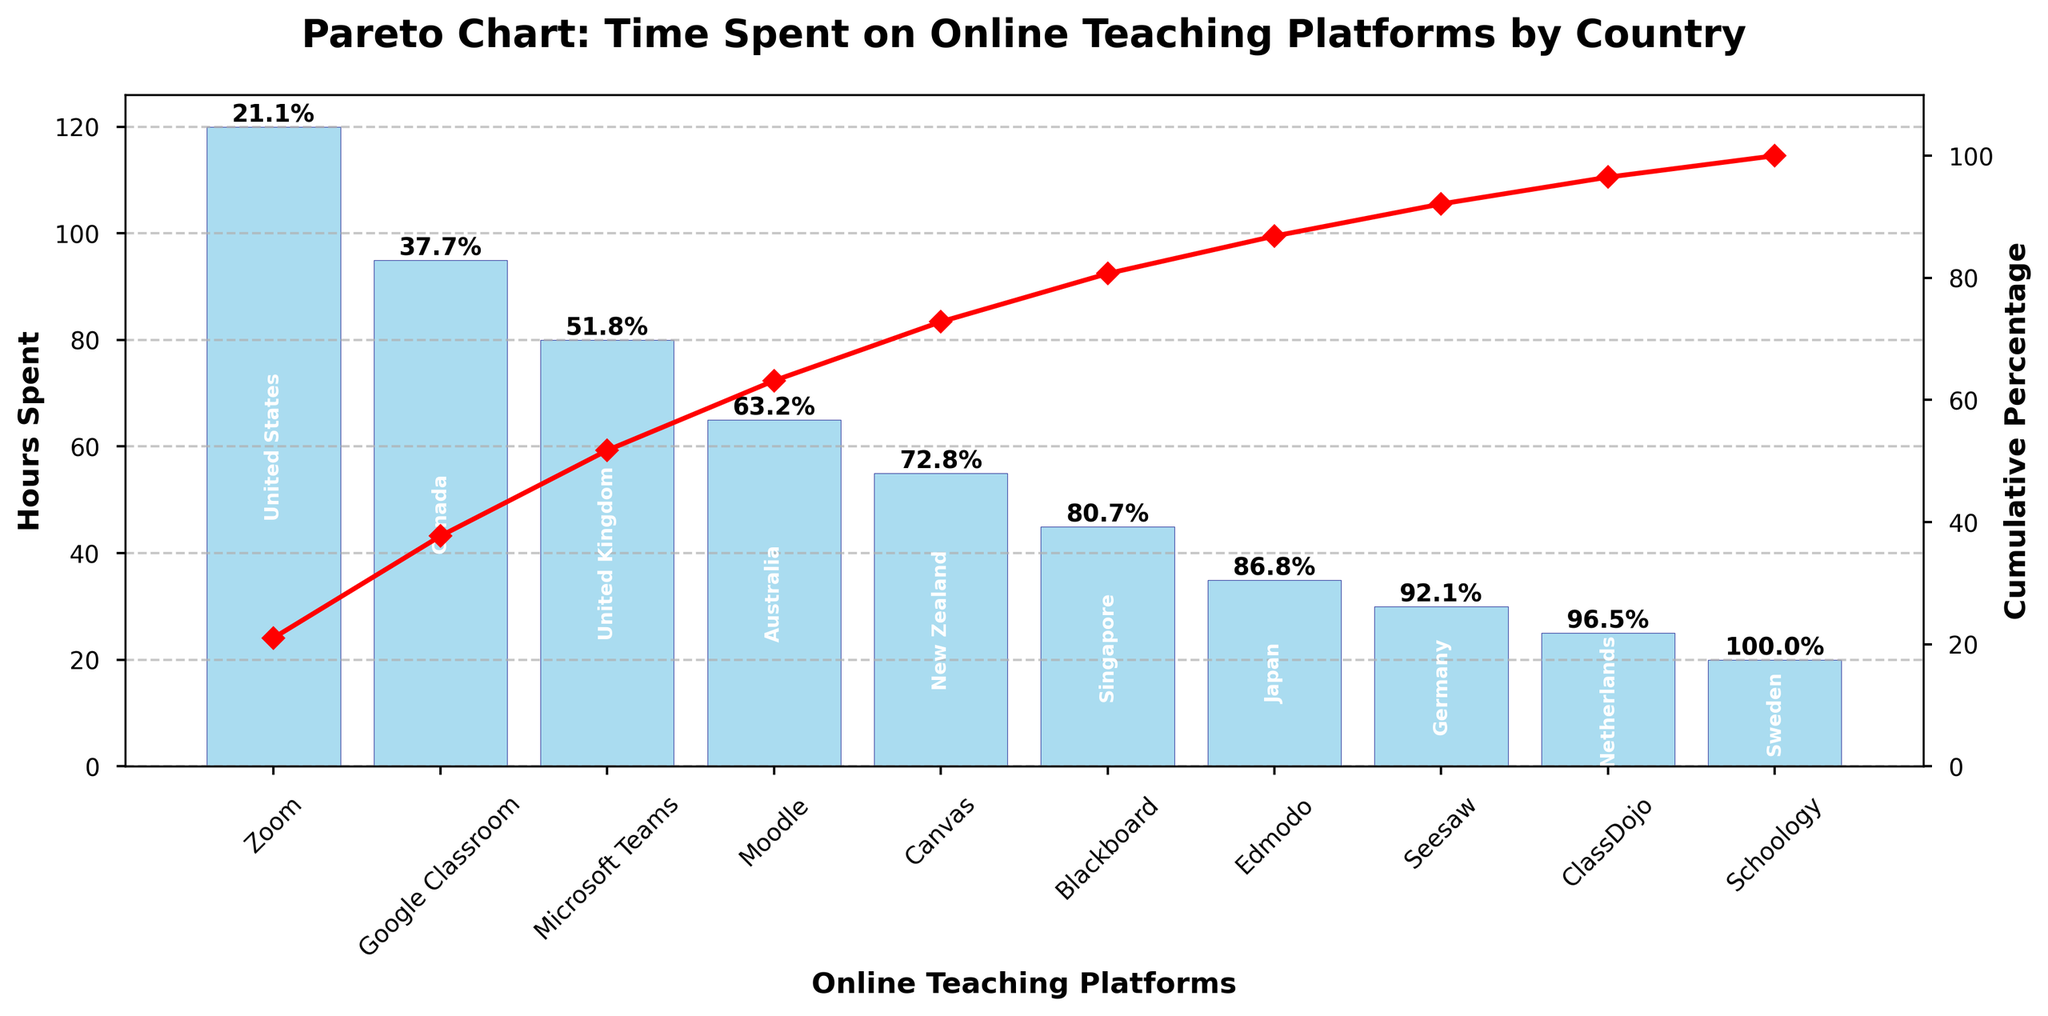What is the title of the figure? The title can be found at the top of the figure, which generally provides a summary of what the figure represents. In this case, it is "Pareto Chart: Time Spent on Online Teaching Platforms by Country"
Answer: Pareto Chart: Time Spent on Online Teaching Platforms by Country Which online teaching platform has the highest hours spent? To find this, look at the highest bar in the figure. The label underneath the tallest bar will indicate the platform.
Answer: Zoom How many hours were spent on the platform Seesaw? To find this information, locate the bar labeled Seesaw and read the height of the bar, which corresponds to the hours spent.
Answer: 30 What is the cumulative percentage after the third platform according to hours spent? Summing the hours of the top three platforms (Zoom, Google Classroom, and Microsoft Teams) gives us 120 + 95 + 80 = 295. Dividing this by the total hours and multiplying by 100 gives the cumulative percentage. The exact values are marked on the chart.
Answer: 64.2% Which country spent time on the platform Canvas? The name of the country for each platform is labeled inside the corresponding bar. Locate the bar for Canvas and find the country label.
Answer: New Zealand What is the total number of hours spent on all platforms? Sum the hours spent on all platforms using the heights of the bars: (120 + 95 + 80 + 65 + 55 + 45 + 35 + 30 + 25 + 20). Adding these together gives 570 hours.
Answer: 570 How much more time was spent on Zoom compared to Edmodo? Subtract the hours spent on Edmodo from the hours spent on Zoom. 120 (Zoom) - 35 (Edmodo) = 85.
Answer: 85 Which platform contribute to 50% of the cumulative percentage? Look at the cumulative percentage line and find the closest points that add up to 50%. Check the platforms corresponding to these points.
Answer: Zoom and Google Classroom What is the cumulative percentage for Schoology? Locate the platform Schoology and observe the cumulative percentage value marked on the chart above this platform's bar.
Answer: 100% What is the difference in hours spent between the platform with the lowest hours spent and the highest hours spent? Subtract the hours spent on Schoology (20) from the hours spent on Zoom (120). The difference is 120 - 20.
Answer: 100 